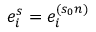Convert formula to latex. <formula><loc_0><loc_0><loc_500><loc_500>e _ { i } ^ { s } = e _ { i } ^ { ( s _ { 0 } n ) }</formula> 